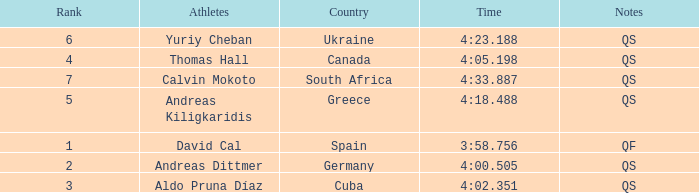What is Calvin Mokoto's average rank? 7.0. 